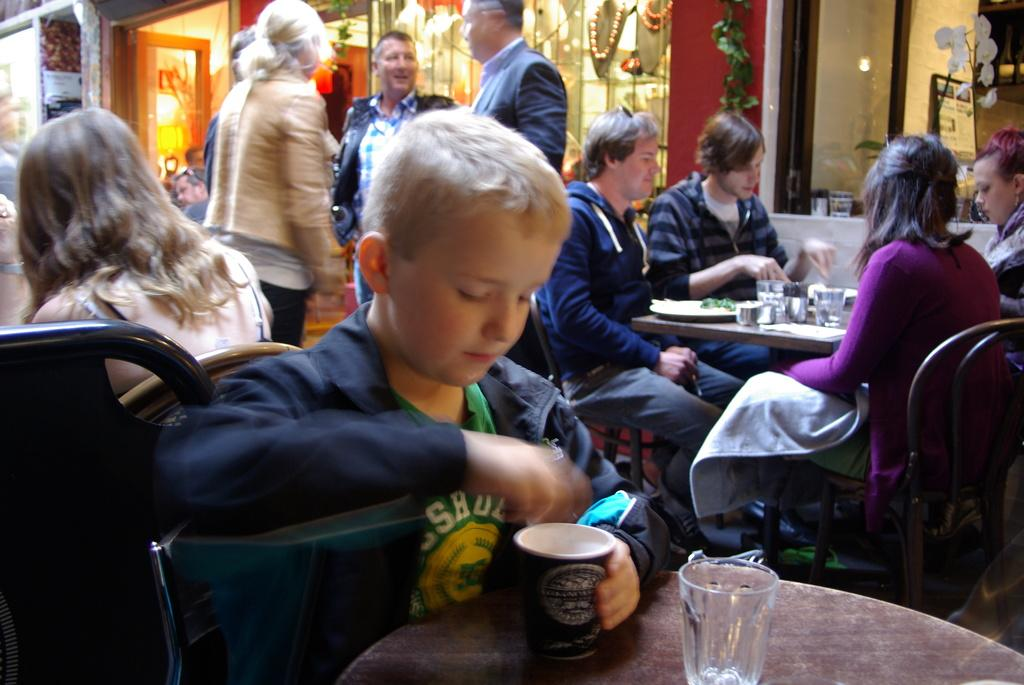What are the people in the image doing? The people in the image are sitting on chairs and having food. How many standing persons are there in the image? There are four persons standing in the image. What are the standing persons doing? The standing persons are having a conversation. What type of farmer is visible in the image? There is no farmer present in the image. What achievements have the standing persons accomplished, as seen in the image? The image does not provide information about the achievements of the standing persons. 